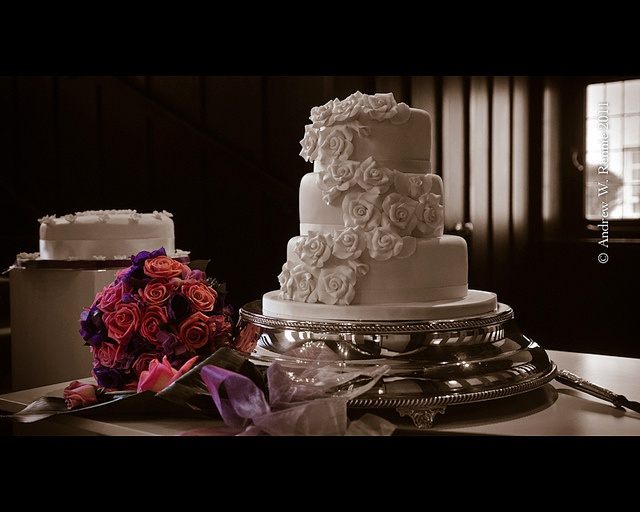Describe the objects in this image and their specific colors. I can see cake in black, maroon, gray, and darkgray tones, dining table in black, gray, and darkgray tones, cake in black, gray, darkgray, and maroon tones, and knife in black, maroon, and gray tones in this image. 